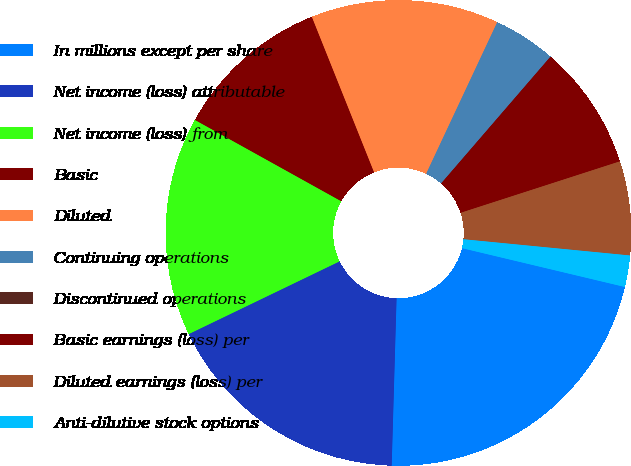Convert chart. <chart><loc_0><loc_0><loc_500><loc_500><pie_chart><fcel>In millions except per share<fcel>Net income (loss) attributable<fcel>Net income (loss) from<fcel>Basic<fcel>Diluted<fcel>Continuing operations<fcel>Discontinued operations<fcel>Basic earnings (loss) per<fcel>Diluted earnings (loss) per<fcel>Anti-dilutive stock options<nl><fcel>21.74%<fcel>17.39%<fcel>15.22%<fcel>10.87%<fcel>13.04%<fcel>4.35%<fcel>0.0%<fcel>8.7%<fcel>6.52%<fcel>2.18%<nl></chart> 